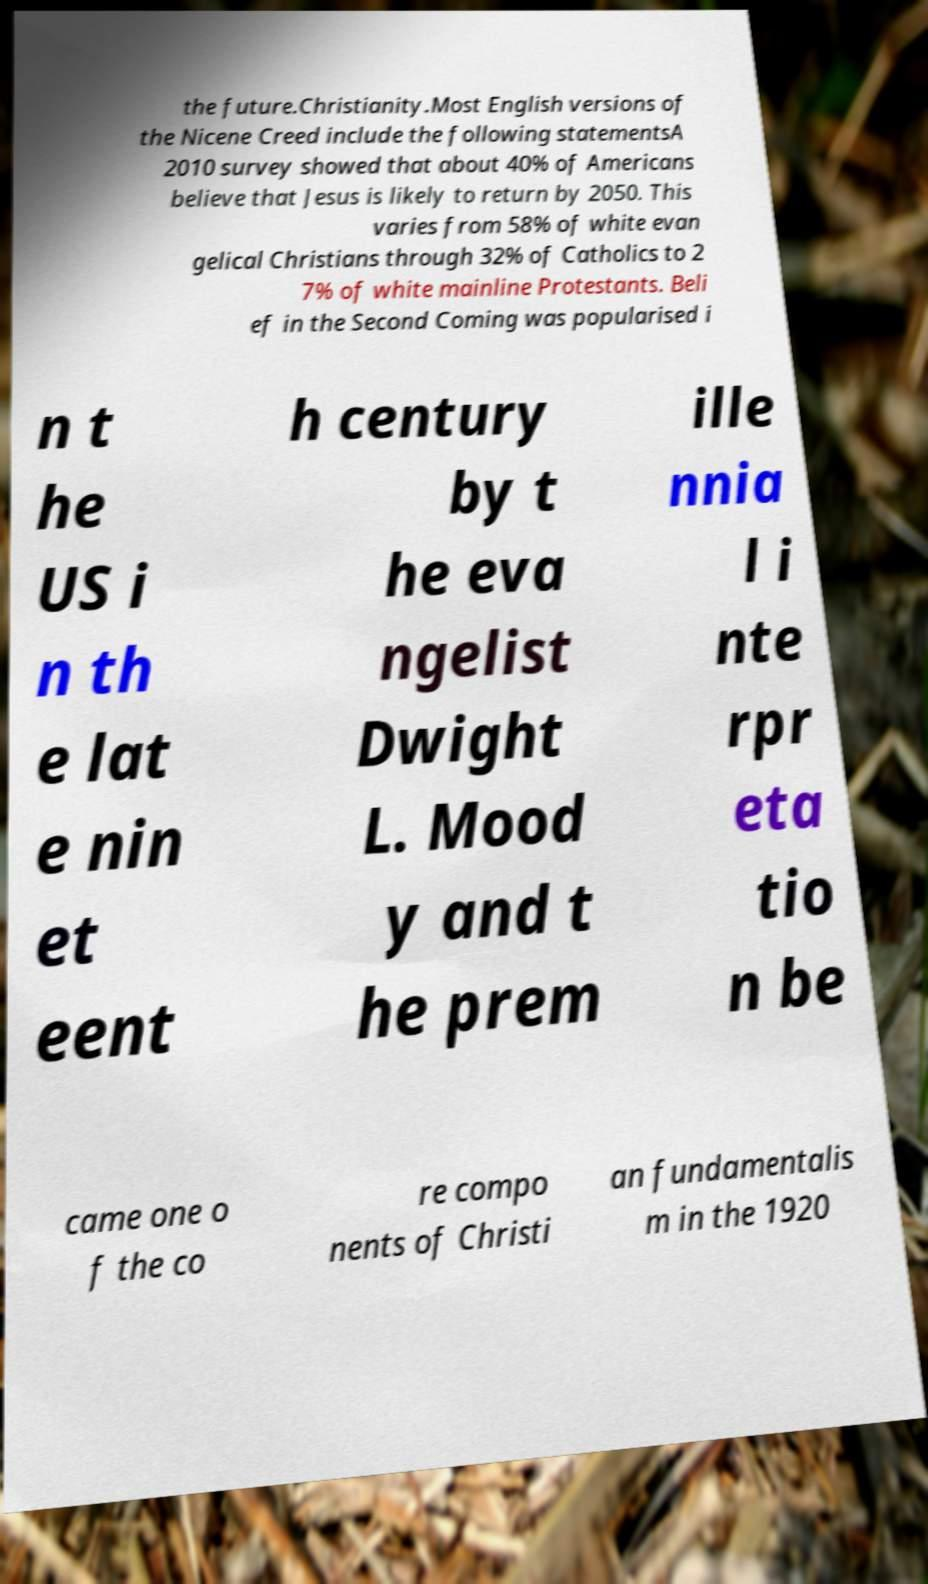Can you accurately transcribe the text from the provided image for me? the future.Christianity.Most English versions of the Nicene Creed include the following statementsA 2010 survey showed that about 40% of Americans believe that Jesus is likely to return by 2050. This varies from 58% of white evan gelical Christians through 32% of Catholics to 2 7% of white mainline Protestants. Beli ef in the Second Coming was popularised i n t he US i n th e lat e nin et eent h century by t he eva ngelist Dwight L. Mood y and t he prem ille nnia l i nte rpr eta tio n be came one o f the co re compo nents of Christi an fundamentalis m in the 1920 